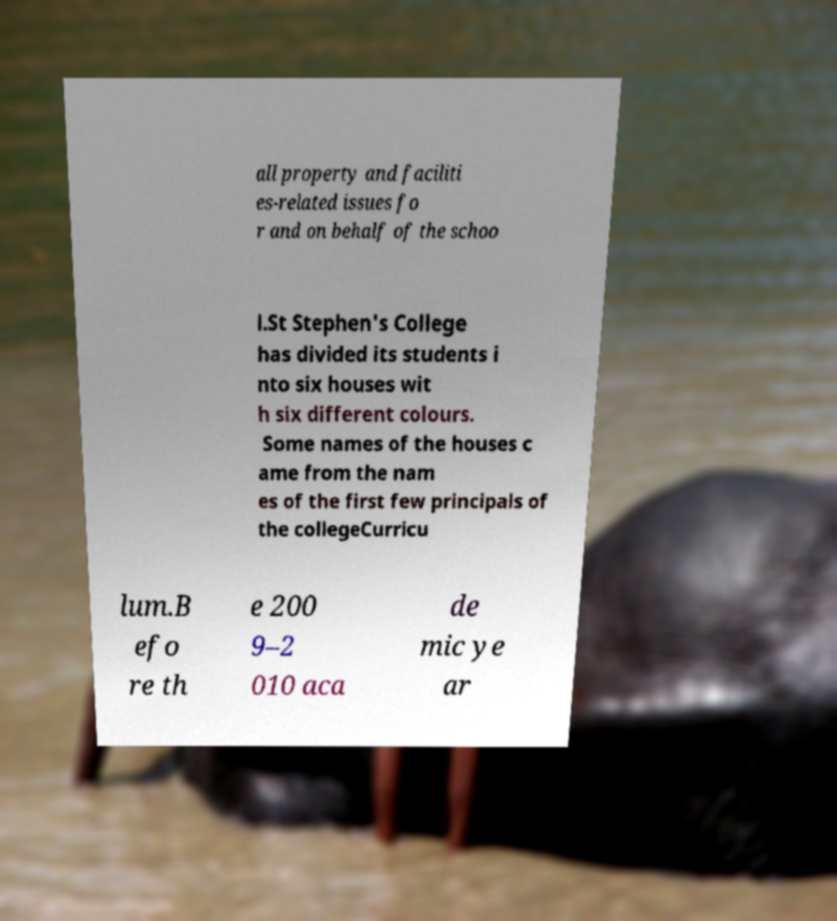Please read and relay the text visible in this image. What does it say? all property and faciliti es-related issues fo r and on behalf of the schoo l.St Stephen's College has divided its students i nto six houses wit h six different colours. Some names of the houses c ame from the nam es of the first few principals of the collegeCurricu lum.B efo re th e 200 9–2 010 aca de mic ye ar 